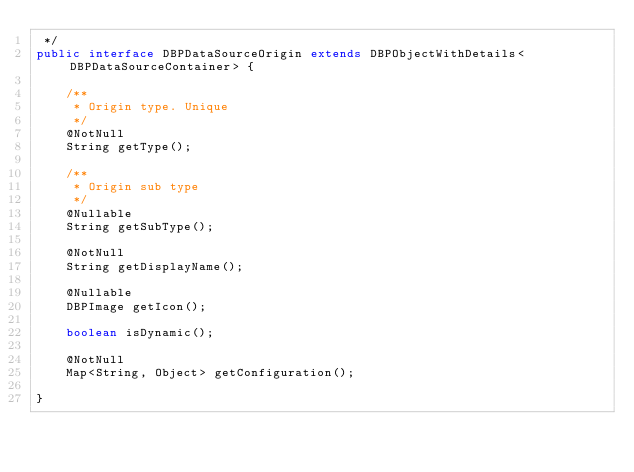<code> <loc_0><loc_0><loc_500><loc_500><_Java_> */
public interface DBPDataSourceOrigin extends DBPObjectWithDetails<DBPDataSourceContainer> {

    /**
     * Origin type. Unique
     */
    @NotNull
    String getType();

    /**
     * Origin sub type
     */
    @Nullable
    String getSubType();

    @NotNull
    String getDisplayName();

    @Nullable
    DBPImage getIcon();

    boolean isDynamic();

    @NotNull
    Map<String, Object> getConfiguration();

}
</code> 